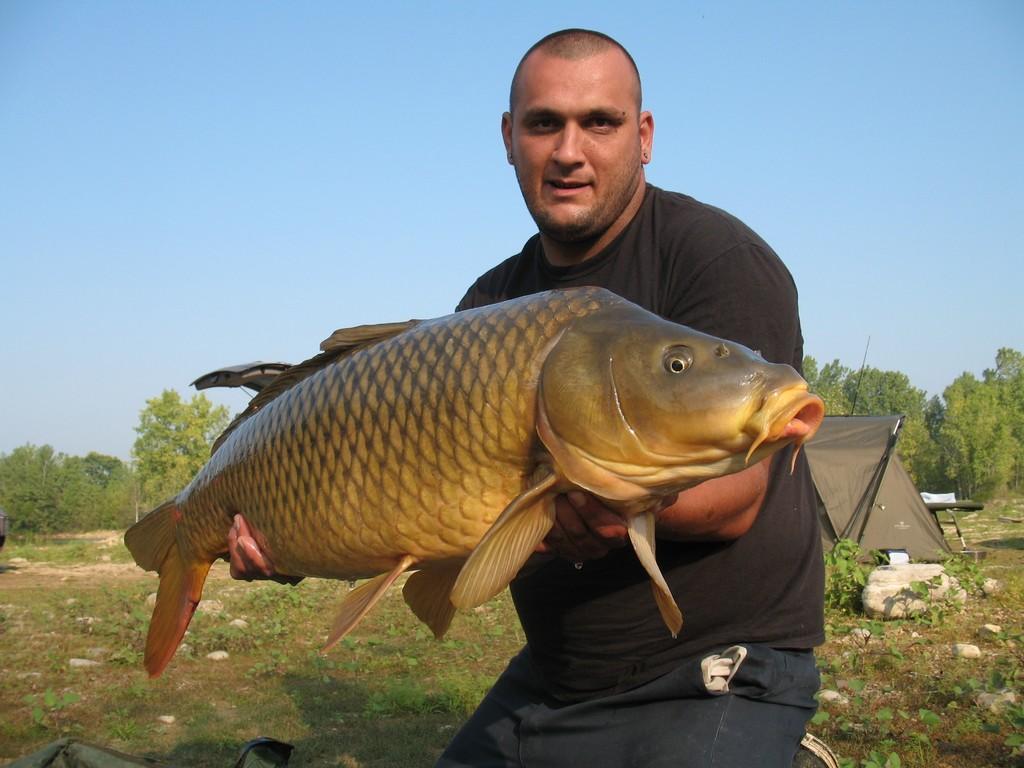Can you describe this image briefly? In the center of the image there is a person holding a fish. In the background we can see trees, tent, plants, stones and sky. 